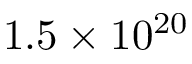<formula> <loc_0><loc_0><loc_500><loc_500>1 . 5 \times 1 0 ^ { 2 0 }</formula> 